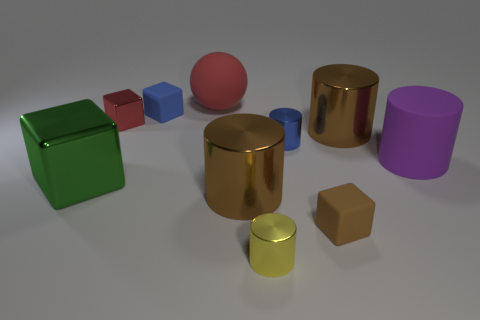How many brown cylinders must be subtracted to get 1 brown cylinders? 1 Subtract all small cylinders. How many cylinders are left? 3 Subtract all yellow cylinders. How many cylinders are left? 4 Subtract 1 balls. How many balls are left? 0 Subtract all balls. How many objects are left? 9 Subtract all green cylinders. Subtract all cyan spheres. How many cylinders are left? 5 Subtract all blue cylinders. How many green cubes are left? 1 Subtract all yellow matte cylinders. Subtract all big red balls. How many objects are left? 9 Add 6 metallic cylinders. How many metallic cylinders are left? 10 Add 1 large red rubber things. How many large red rubber things exist? 2 